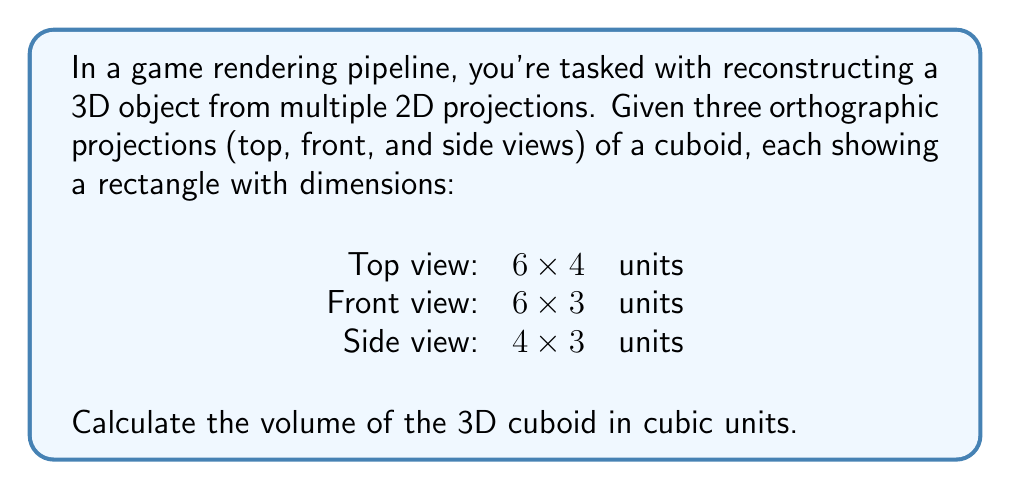Can you answer this question? Let's approach this step-by-step, using our knowledge of 3D object reconstruction from 2D projections:

1) In orthographic projections, each view represents the true dimensions of the object along two axes:

   - Top view (6x4): Shows the length and width
   - Front view (6x3): Shows the length and height
   - Side view (4x3): Shows the width and height

2) From these projections, we can determine the dimensions of the cuboid:

   - Length: 6 units (consistent in top and front views)
   - Width: 4 units (consistent in top and side views)
   - Height: 3 units (consistent in front and side views)

3) The volume of a cuboid is calculated using the formula:

   $$ V = l \times w \times h $$

   Where:
   $V$ = volume
   $l$ = length
   $w$ = width
   $h$ = height

4) Substituting our values:

   $$ V = 6 \times 4 \times 3 $$

5) Calculating:

   $$ V = 72 $$

Therefore, the volume of the cuboid is 72 cubic units.

This process is similar to how game engines might reconstruct 3D objects from multiple 2D sprites or textures, although in practice, more complex algorithms and additional data (like depth information) are often used for accurate 3D reconstruction.
Answer: 72 cubic units 